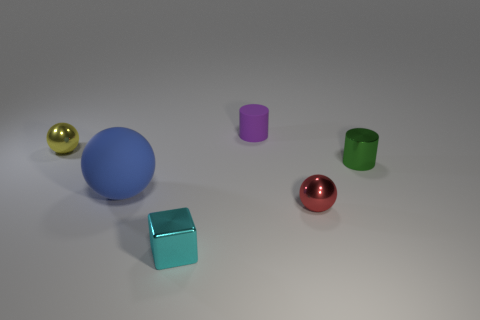Subtract all small metallic spheres. How many spheres are left? 1 Add 2 small blue matte objects. How many objects exist? 8 Subtract all cylinders. How many objects are left? 4 Subtract all tiny yellow balls. Subtract all green shiny cylinders. How many objects are left? 4 Add 3 blue matte balls. How many blue matte balls are left? 4 Add 5 red rubber balls. How many red rubber balls exist? 5 Subtract 0 brown cylinders. How many objects are left? 6 